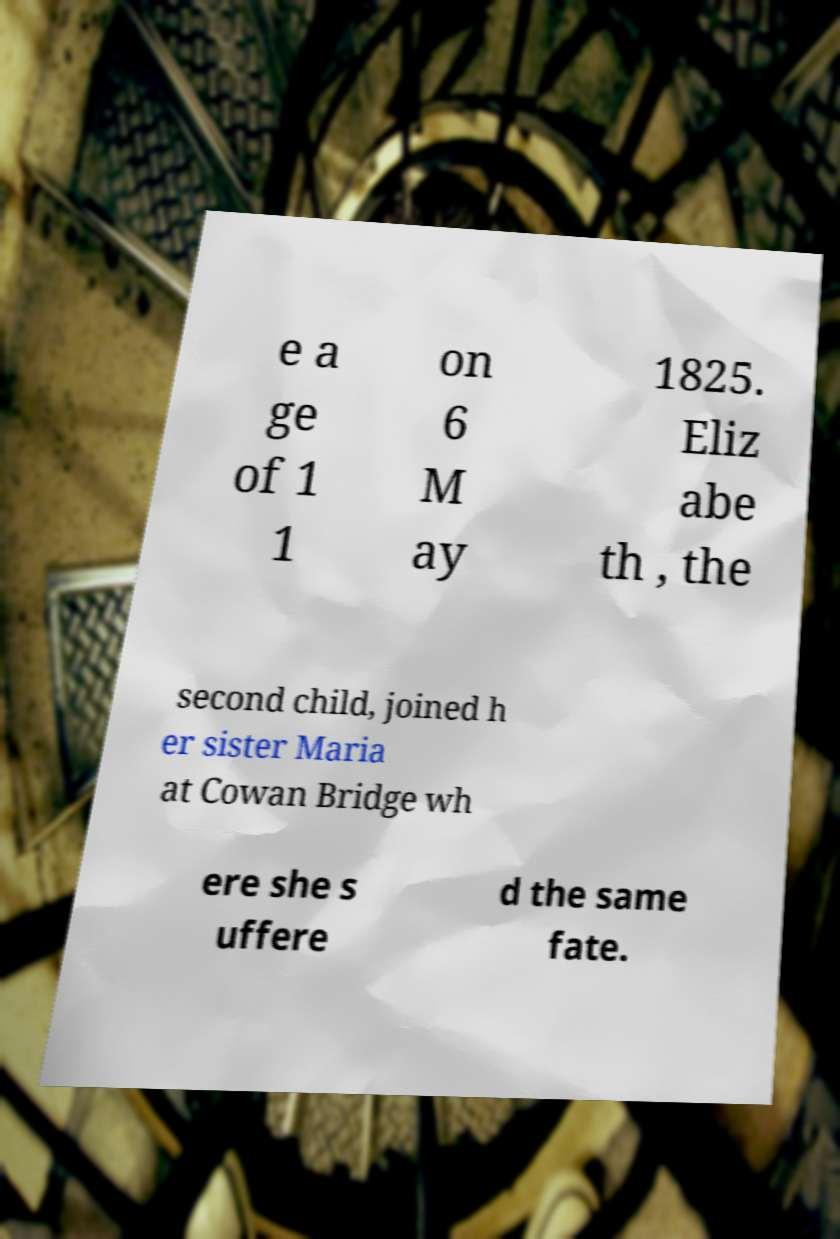Can you read and provide the text displayed in the image?This photo seems to have some interesting text. Can you extract and type it out for me? e a ge of 1 1 on 6 M ay 1825. Eliz abe th , the second child, joined h er sister Maria at Cowan Bridge wh ere she s uffere d the same fate. 